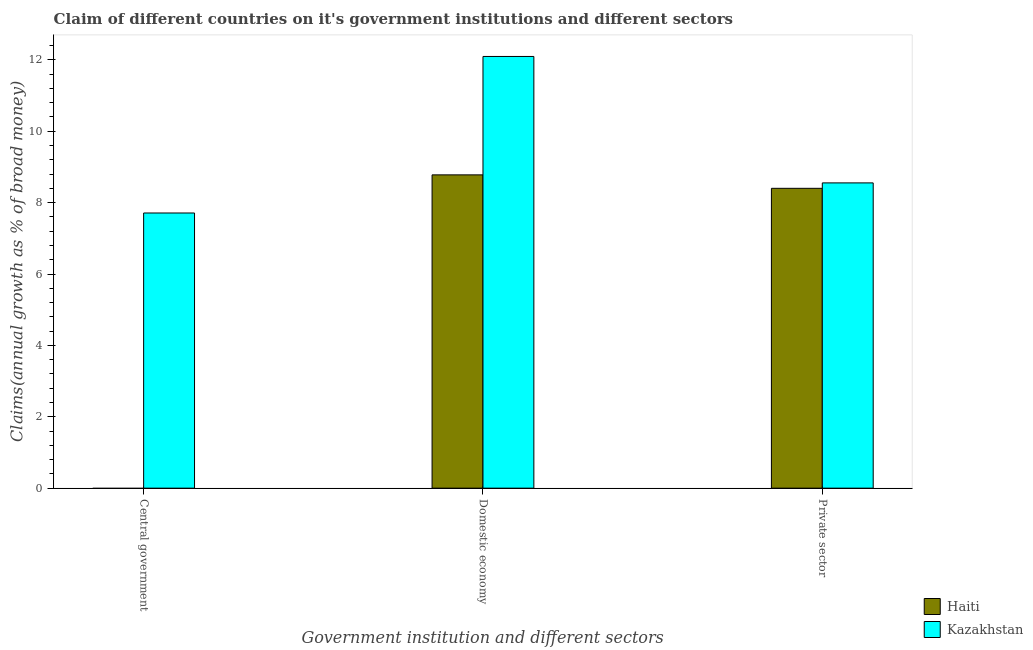Are the number of bars on each tick of the X-axis equal?
Your answer should be compact. No. How many bars are there on the 1st tick from the left?
Offer a terse response. 1. What is the label of the 3rd group of bars from the left?
Keep it short and to the point. Private sector. What is the percentage of claim on the private sector in Haiti?
Your answer should be compact. 8.4. Across all countries, what is the maximum percentage of claim on the private sector?
Your answer should be very brief. 8.55. Across all countries, what is the minimum percentage of claim on the domestic economy?
Your answer should be very brief. 8.78. In which country was the percentage of claim on the central government maximum?
Your answer should be very brief. Kazakhstan. What is the total percentage of claim on the private sector in the graph?
Your response must be concise. 16.95. What is the difference between the percentage of claim on the private sector in Kazakhstan and that in Haiti?
Provide a short and direct response. 0.15. What is the difference between the percentage of claim on the private sector in Kazakhstan and the percentage of claim on the domestic economy in Haiti?
Ensure brevity in your answer.  -0.22. What is the average percentage of claim on the domestic economy per country?
Make the answer very short. 10.44. What is the difference between the percentage of claim on the central government and percentage of claim on the private sector in Kazakhstan?
Make the answer very short. -0.84. What is the ratio of the percentage of claim on the private sector in Kazakhstan to that in Haiti?
Your answer should be compact. 1.02. Is the percentage of claim on the private sector in Haiti less than that in Kazakhstan?
Give a very brief answer. Yes. What is the difference between the highest and the second highest percentage of claim on the domestic economy?
Your answer should be very brief. 3.32. What is the difference between the highest and the lowest percentage of claim on the domestic economy?
Provide a short and direct response. 3.32. In how many countries, is the percentage of claim on the domestic economy greater than the average percentage of claim on the domestic economy taken over all countries?
Keep it short and to the point. 1. Is the sum of the percentage of claim on the private sector in Kazakhstan and Haiti greater than the maximum percentage of claim on the domestic economy across all countries?
Provide a succinct answer. Yes. Are all the bars in the graph horizontal?
Your response must be concise. No. What is the difference between two consecutive major ticks on the Y-axis?
Keep it short and to the point. 2. Does the graph contain grids?
Give a very brief answer. No. Where does the legend appear in the graph?
Your answer should be compact. Bottom right. What is the title of the graph?
Offer a terse response. Claim of different countries on it's government institutions and different sectors. Does "South Sudan" appear as one of the legend labels in the graph?
Your response must be concise. No. What is the label or title of the X-axis?
Your response must be concise. Government institution and different sectors. What is the label or title of the Y-axis?
Your response must be concise. Claims(annual growth as % of broad money). What is the Claims(annual growth as % of broad money) of Haiti in Central government?
Offer a very short reply. 0. What is the Claims(annual growth as % of broad money) in Kazakhstan in Central government?
Provide a succinct answer. 7.71. What is the Claims(annual growth as % of broad money) in Haiti in Domestic economy?
Ensure brevity in your answer.  8.78. What is the Claims(annual growth as % of broad money) of Kazakhstan in Domestic economy?
Ensure brevity in your answer.  12.1. What is the Claims(annual growth as % of broad money) of Haiti in Private sector?
Give a very brief answer. 8.4. What is the Claims(annual growth as % of broad money) of Kazakhstan in Private sector?
Ensure brevity in your answer.  8.55. Across all Government institution and different sectors, what is the maximum Claims(annual growth as % of broad money) in Haiti?
Ensure brevity in your answer.  8.78. Across all Government institution and different sectors, what is the maximum Claims(annual growth as % of broad money) of Kazakhstan?
Your response must be concise. 12.1. Across all Government institution and different sectors, what is the minimum Claims(annual growth as % of broad money) of Haiti?
Your answer should be very brief. 0. Across all Government institution and different sectors, what is the minimum Claims(annual growth as % of broad money) in Kazakhstan?
Keep it short and to the point. 7.71. What is the total Claims(annual growth as % of broad money) of Haiti in the graph?
Give a very brief answer. 17.18. What is the total Claims(annual growth as % of broad money) of Kazakhstan in the graph?
Make the answer very short. 28.36. What is the difference between the Claims(annual growth as % of broad money) of Kazakhstan in Central government and that in Domestic economy?
Your answer should be very brief. -4.39. What is the difference between the Claims(annual growth as % of broad money) in Kazakhstan in Central government and that in Private sector?
Ensure brevity in your answer.  -0.84. What is the difference between the Claims(annual growth as % of broad money) in Haiti in Domestic economy and that in Private sector?
Ensure brevity in your answer.  0.38. What is the difference between the Claims(annual growth as % of broad money) of Kazakhstan in Domestic economy and that in Private sector?
Keep it short and to the point. 3.54. What is the difference between the Claims(annual growth as % of broad money) of Haiti in Domestic economy and the Claims(annual growth as % of broad money) of Kazakhstan in Private sector?
Provide a short and direct response. 0.22. What is the average Claims(annual growth as % of broad money) of Haiti per Government institution and different sectors?
Offer a very short reply. 5.73. What is the average Claims(annual growth as % of broad money) of Kazakhstan per Government institution and different sectors?
Offer a terse response. 9.45. What is the difference between the Claims(annual growth as % of broad money) of Haiti and Claims(annual growth as % of broad money) of Kazakhstan in Domestic economy?
Provide a short and direct response. -3.32. What is the difference between the Claims(annual growth as % of broad money) of Haiti and Claims(annual growth as % of broad money) of Kazakhstan in Private sector?
Provide a short and direct response. -0.15. What is the ratio of the Claims(annual growth as % of broad money) in Kazakhstan in Central government to that in Domestic economy?
Provide a short and direct response. 0.64. What is the ratio of the Claims(annual growth as % of broad money) of Kazakhstan in Central government to that in Private sector?
Your response must be concise. 0.9. What is the ratio of the Claims(annual growth as % of broad money) of Haiti in Domestic economy to that in Private sector?
Offer a very short reply. 1.04. What is the ratio of the Claims(annual growth as % of broad money) in Kazakhstan in Domestic economy to that in Private sector?
Provide a short and direct response. 1.41. What is the difference between the highest and the second highest Claims(annual growth as % of broad money) of Kazakhstan?
Make the answer very short. 3.54. What is the difference between the highest and the lowest Claims(annual growth as % of broad money) in Haiti?
Offer a terse response. 8.78. What is the difference between the highest and the lowest Claims(annual growth as % of broad money) of Kazakhstan?
Offer a very short reply. 4.39. 